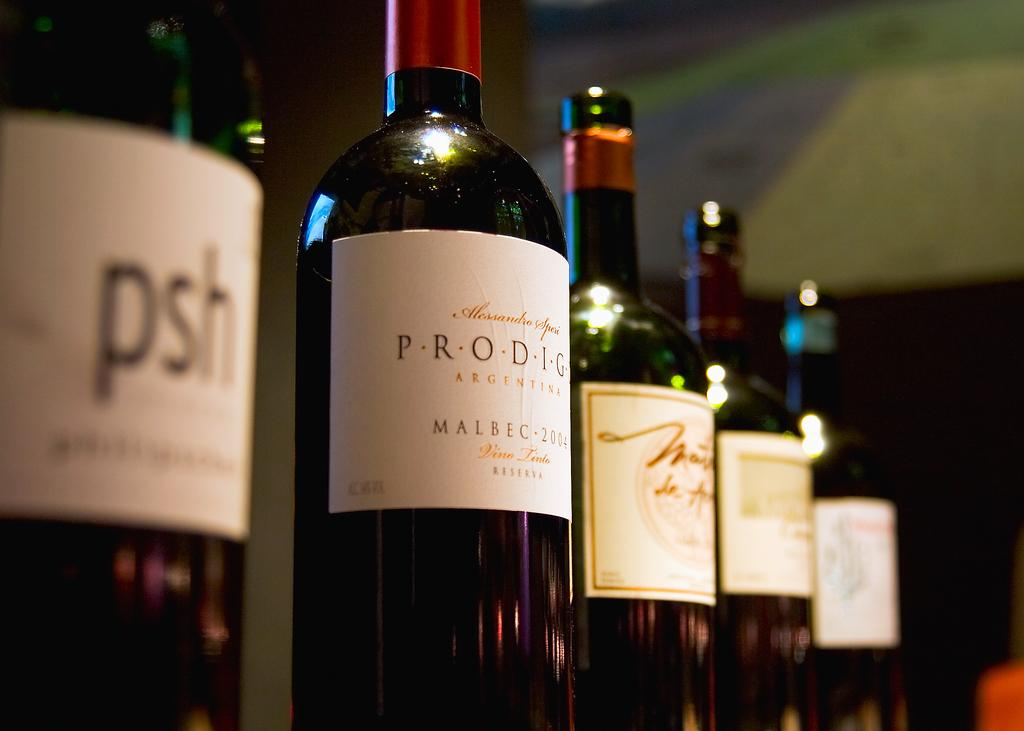What objects are present in the image? There are bottles in the image. How are the bottles arranged? The bottles are arranged in a series. Where are the bottles located in the image? The bottles are located in the center of the image. What type of calculator is being used in the image? There is no calculator present in the image; it only features bottles arranged in a series. 